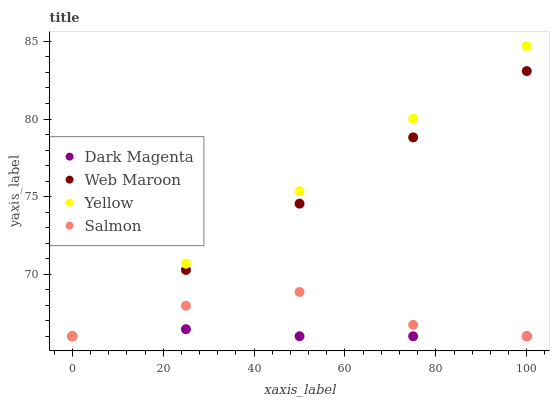Does Dark Magenta have the minimum area under the curve?
Answer yes or no. Yes. Does Yellow have the maximum area under the curve?
Answer yes or no. Yes. Does Web Maroon have the minimum area under the curve?
Answer yes or no. No. Does Web Maroon have the maximum area under the curve?
Answer yes or no. No. Is Web Maroon the smoothest?
Answer yes or no. Yes. Is Salmon the roughest?
Answer yes or no. Yes. Is Dark Magenta the smoothest?
Answer yes or no. No. Is Dark Magenta the roughest?
Answer yes or no. No. Does Salmon have the lowest value?
Answer yes or no. Yes. Does Yellow have the highest value?
Answer yes or no. Yes. Does Web Maroon have the highest value?
Answer yes or no. No. Does Yellow intersect Salmon?
Answer yes or no. Yes. Is Yellow less than Salmon?
Answer yes or no. No. Is Yellow greater than Salmon?
Answer yes or no. No. 